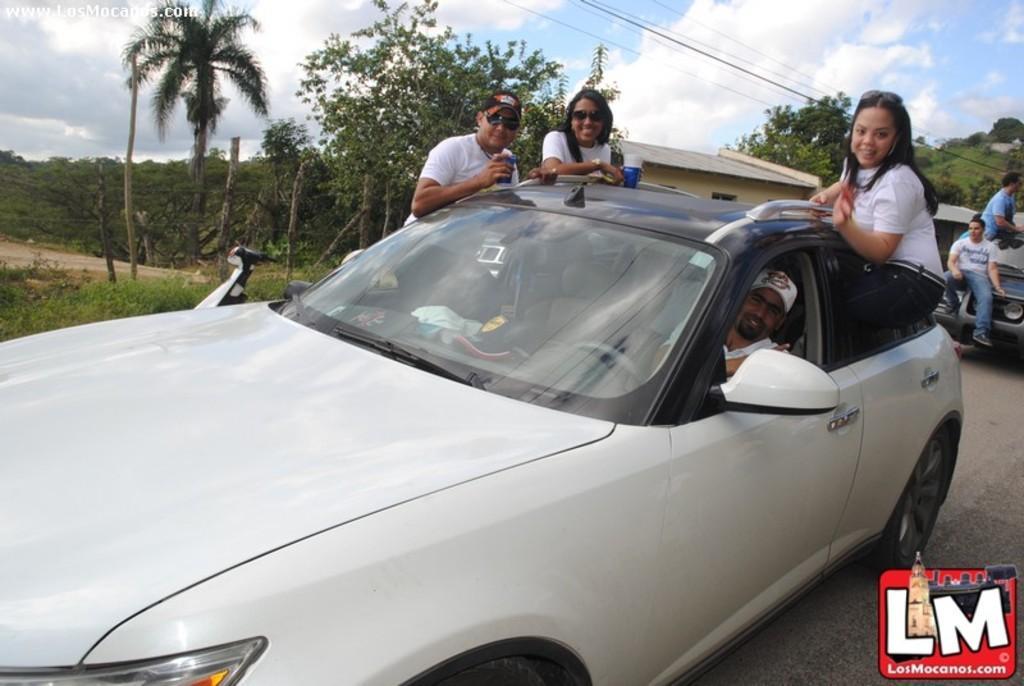Please provide a concise description of this image. In this image there are people sitting in the car. Beside the car there is a bike. At the bottom of the image there is grass on the surface. In the background of the image there are trees and sky. There is some text at the top of the image. There is a watermark at the bottom of the image. 